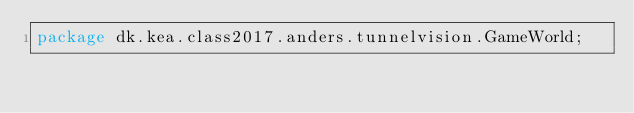<code> <loc_0><loc_0><loc_500><loc_500><_Java_>package dk.kea.class2017.anders.tunnelvision.GameWorld;

</code> 